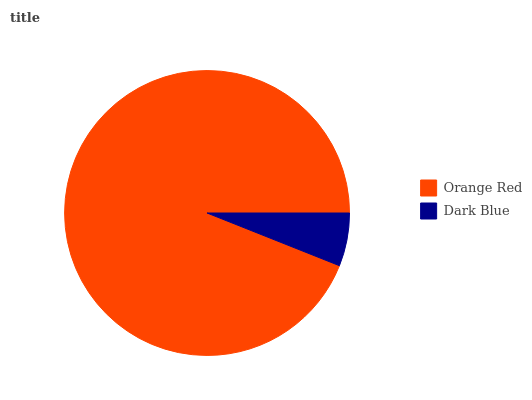Is Dark Blue the minimum?
Answer yes or no. Yes. Is Orange Red the maximum?
Answer yes or no. Yes. Is Dark Blue the maximum?
Answer yes or no. No. Is Orange Red greater than Dark Blue?
Answer yes or no. Yes. Is Dark Blue less than Orange Red?
Answer yes or no. Yes. Is Dark Blue greater than Orange Red?
Answer yes or no. No. Is Orange Red less than Dark Blue?
Answer yes or no. No. Is Orange Red the high median?
Answer yes or no. Yes. Is Dark Blue the low median?
Answer yes or no. Yes. Is Dark Blue the high median?
Answer yes or no. No. Is Orange Red the low median?
Answer yes or no. No. 